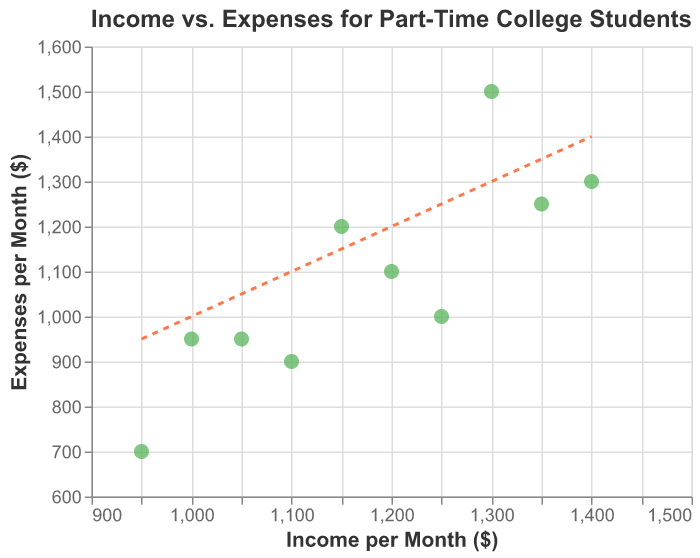How many data points are in the figure? Count the number of distinct points in the scatter plot. There are 10 students with their income and expenses data plotted.
Answer: 10 What color are the points representing students' data? Observe the color used for the points in the scatter plot. The points are colored green.
Answer: Green What are the maximum and minimum income values shown in the scatter plot? Look at the x-axis range and identify the highest and lowest points plotted along the x-axis for income values. The minimum income is 950, and the maximum income is 1400.
Answer: Minimum: 950, Maximum: 1400 Which student has the highest expenses, and what is the value? Find the highest data point on the y-axis representing expenses, and check the tooltip or legend to identify the student. Emily has the highest expenses, which are 1500.
Answer: Emily, 1500 Which student has the lowest expenses, and what is the value? Find the lowest data point on the y-axis representing expenses, and check the tooltip or legend to identify the student. Chris has the lowest expenses, which are 700.
Answer: Chris, 700 What is the difference between the income and expenses of David? Identify David's coordinates on the scatter plot and subtract his expenses from his income. David's income is 1400, and his expenses are 1300, so the difference is 1400 - 1300.
Answer: 100 Is there any student whose expenses are higher than their income? Check the data points located above the dashed line (x = y) where expenses (y) are higher than income (x). Emily and Sarah have expenses higher than their income.
Answer: Emily, Sarah Calculate the average income of all students in the scatter plot. Sum all income values and divide by the total number of students. (1200 + 1300 + 950 + 1100 + 1050 + 1250 + 1000 + 1150 + 1400 + 1350) / 10 = 11750 / 10.
Answer: 1175 What is the average value of expenses for students whose income is greater than or equal to 1200? Select students with incomes >= 1200 and calculate the average of their expenses. (1100 (John) + 1500 (Emily) + 1000 (Laura) + 1200 (Sarah) + 1300 (David) + 1250 (Jessica)) / 6 = 7350 / 6.
Answer: 1225 Who has the closest expenses to their income and what is the value of the difference? Locate the data points nearest to the dashed line (x = y), and calculate the difference. John and Andrew have the closest matching expenses and income with a difference of 100 respectively.
Answer: John, Andrew, Difference: 100 